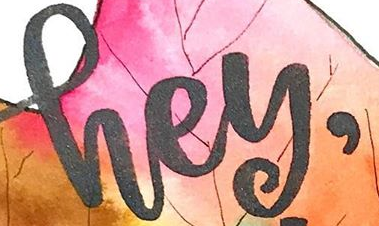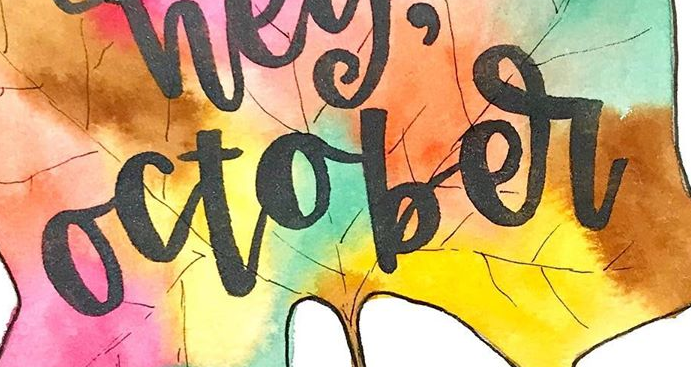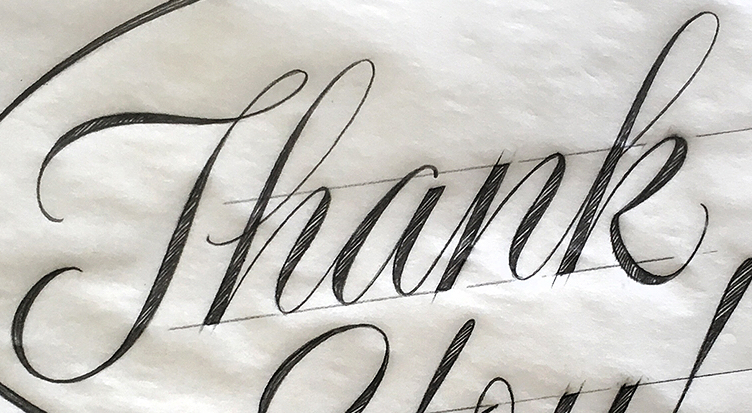What words are shown in these images in order, separated by a semicolon? hey,; october; Thank 